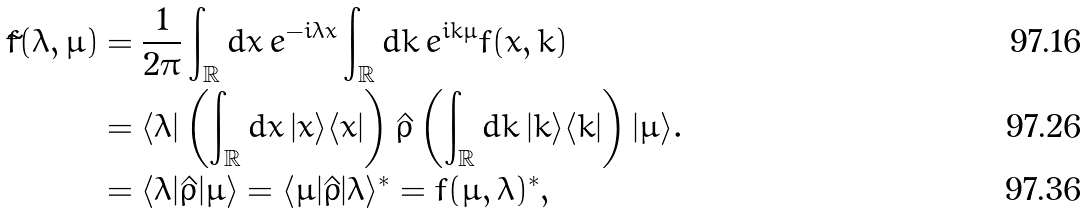Convert formula to latex. <formula><loc_0><loc_0><loc_500><loc_500>\tilde { f } ( \lambda , \mu ) & = \frac { 1 } { 2 \pi } \int _ { \mathbb { R } } d x \, e ^ { - i \lambda x } \int _ { \mathbb { R } } d k \, e ^ { i k \mu } f ( x , k ) \\ & = \langle \lambda | \left ( \int _ { \mathbb { R } } d x \, | x \rangle \langle x | \right ) \hat { \rho } \left ( \int _ { \mathbb { R } } d k \, | k \rangle \langle k | \right ) | \mu \rangle . \\ & = \langle \lambda | \hat { \rho } | \mu \rangle = \langle \mu | \hat { \rho } | \lambda \rangle ^ { * } = f ( \mu , \lambda ) ^ { * } ,</formula> 